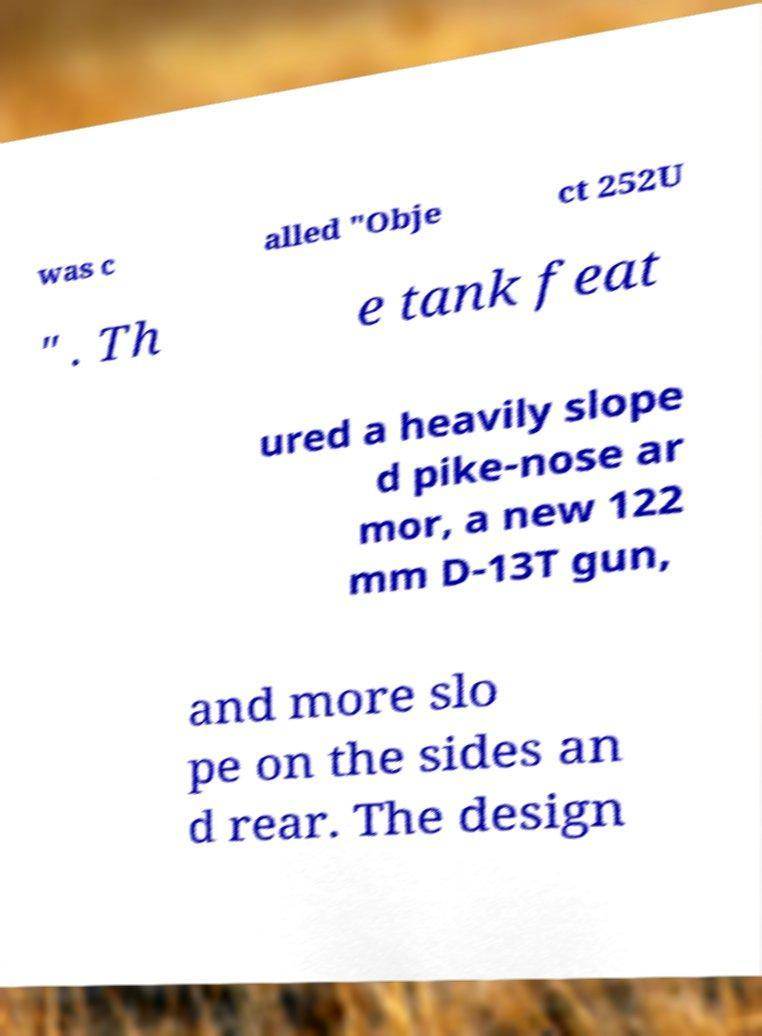For documentation purposes, I need the text within this image transcribed. Could you provide that? was c alled "Obje ct 252U " . Th e tank feat ured a heavily slope d pike-nose ar mor, a new 122 mm D-13T gun, and more slo pe on the sides an d rear. The design 